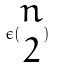Convert formula to latex. <formula><loc_0><loc_0><loc_500><loc_500>\epsilon ( \begin{matrix} n \\ 2 \end{matrix} )</formula> 